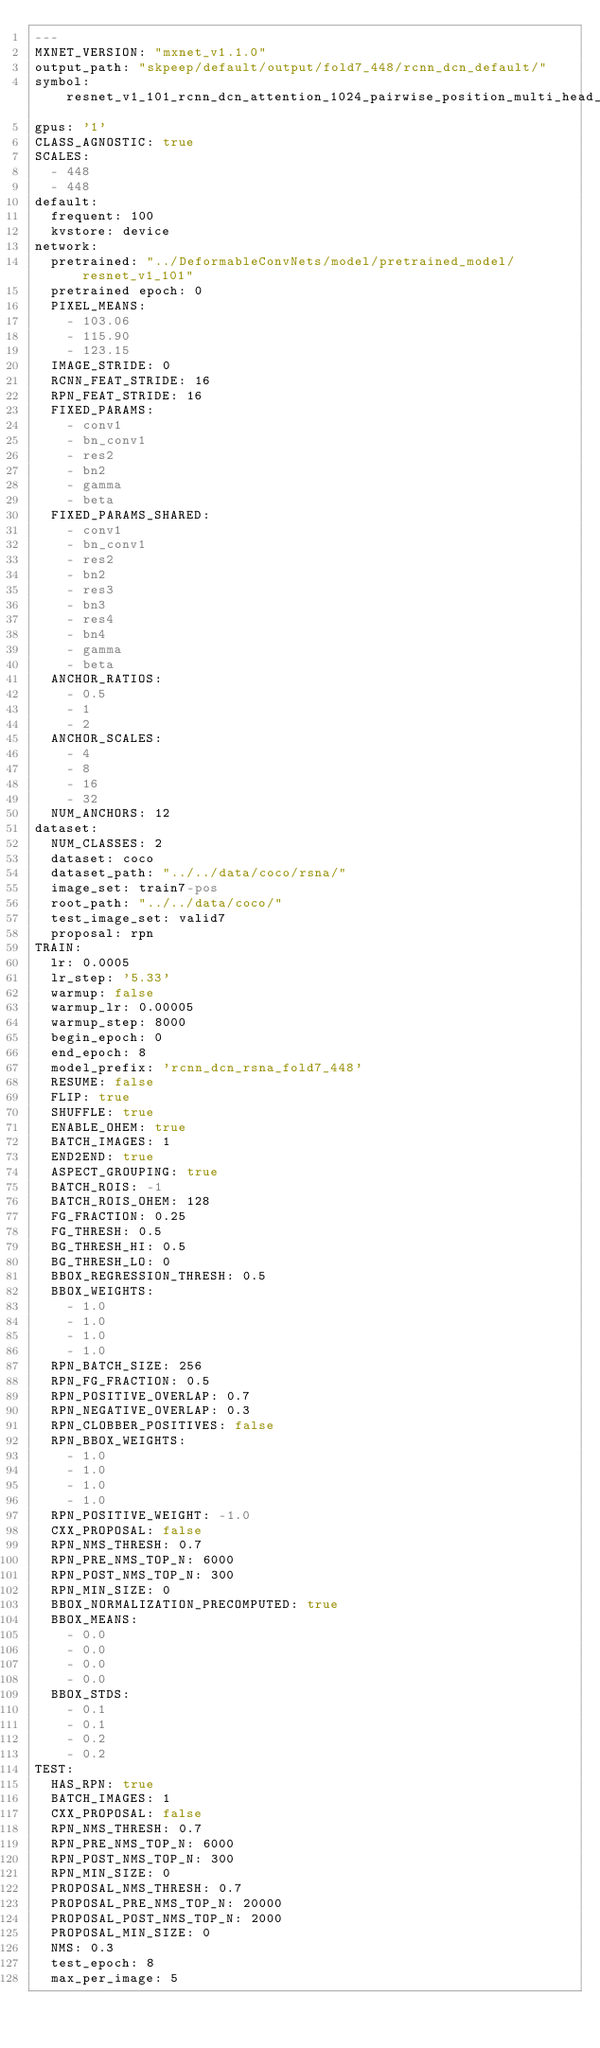Convert code to text. <code><loc_0><loc_0><loc_500><loc_500><_YAML_>---
MXNET_VERSION: "mxnet_v1.1.0"
output_path: "skpeep/default/output/fold7_448/rcnn_dcn_default/"
symbol: resnet_v1_101_rcnn_dcn_attention_1024_pairwise_position_multi_head_16
gpus: '1'
CLASS_AGNOSTIC: true
SCALES:
  - 448
  - 448
default:
  frequent: 100
  kvstore: device
network:
  pretrained: "../DeformableConvNets/model/pretrained_model/resnet_v1_101"
  pretrained epoch: 0
  PIXEL_MEANS:
    - 103.06
    - 115.90
    - 123.15
  IMAGE_STRIDE: 0
  RCNN_FEAT_STRIDE: 16
  RPN_FEAT_STRIDE: 16
  FIXED_PARAMS:
    - conv1
    - bn_conv1
    - res2
    - bn2
    - gamma
    - beta
  FIXED_PARAMS_SHARED:
    - conv1
    - bn_conv1
    - res2
    - bn2
    - res3
    - bn3
    - res4
    - bn4
    - gamma
    - beta
  ANCHOR_RATIOS:
    - 0.5
    - 1
    - 2
  ANCHOR_SCALES:
    - 4
    - 8
    - 16
    - 32
  NUM_ANCHORS: 12
dataset:
  NUM_CLASSES: 2
  dataset: coco
  dataset_path: "../../data/coco/rsna/"
  image_set: train7-pos
  root_path: "../../data/coco/"
  test_image_set: valid7
  proposal: rpn
TRAIN:
  lr: 0.0005
  lr_step: '5.33'
  warmup: false
  warmup_lr: 0.00005
  warmup_step: 8000
  begin_epoch: 0
  end_epoch: 8
  model_prefix: 'rcnn_dcn_rsna_fold7_448'
  RESUME: false
  FLIP: true
  SHUFFLE: true
  ENABLE_OHEM: true
  BATCH_IMAGES: 1
  END2END: true
  ASPECT_GROUPING: true
  BATCH_ROIS: -1
  BATCH_ROIS_OHEM: 128
  FG_FRACTION: 0.25
  FG_THRESH: 0.5
  BG_THRESH_HI: 0.5
  BG_THRESH_LO: 0
  BBOX_REGRESSION_THRESH: 0.5
  BBOX_WEIGHTS:
    - 1.0
    - 1.0
    - 1.0
    - 1.0
  RPN_BATCH_SIZE: 256
  RPN_FG_FRACTION: 0.5
  RPN_POSITIVE_OVERLAP: 0.7
  RPN_NEGATIVE_OVERLAP: 0.3
  RPN_CLOBBER_POSITIVES: false
  RPN_BBOX_WEIGHTS:
    - 1.0
    - 1.0
    - 1.0
    - 1.0
  RPN_POSITIVE_WEIGHT: -1.0
  CXX_PROPOSAL: false
  RPN_NMS_THRESH: 0.7
  RPN_PRE_NMS_TOP_N: 6000
  RPN_POST_NMS_TOP_N: 300
  RPN_MIN_SIZE: 0
  BBOX_NORMALIZATION_PRECOMPUTED: true
  BBOX_MEANS:
    - 0.0
    - 0.0
    - 0.0
    - 0.0
  BBOX_STDS:
    - 0.1
    - 0.1
    - 0.2
    - 0.2
TEST:
  HAS_RPN: true
  BATCH_IMAGES: 1
  CXX_PROPOSAL: false
  RPN_NMS_THRESH: 0.7
  RPN_PRE_NMS_TOP_N: 6000
  RPN_POST_NMS_TOP_N: 300
  RPN_MIN_SIZE: 0
  PROPOSAL_NMS_THRESH: 0.7
  PROPOSAL_PRE_NMS_TOP_N: 20000
  PROPOSAL_POST_NMS_TOP_N: 2000
  PROPOSAL_MIN_SIZE: 0
  NMS: 0.3
  test_epoch: 8
  max_per_image: 5
</code> 